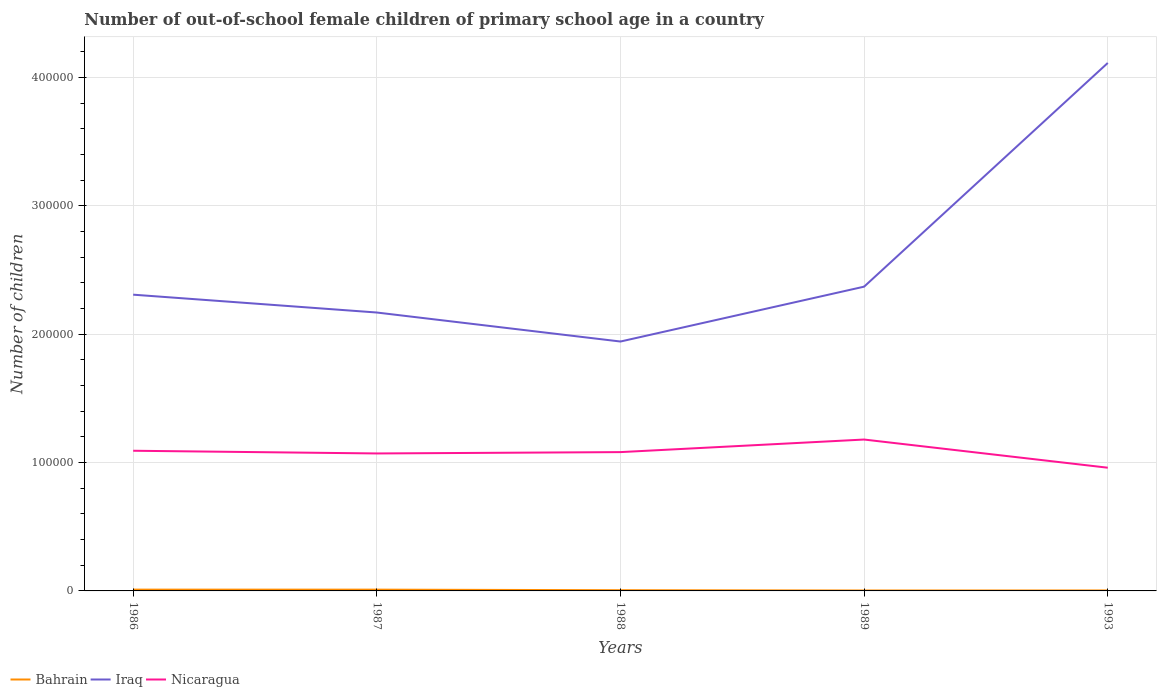How many different coloured lines are there?
Keep it short and to the point. 3. Does the line corresponding to Iraq intersect with the line corresponding to Bahrain?
Your answer should be compact. No. Across all years, what is the maximum number of out-of-school female children in Bahrain?
Offer a very short reply. 341. What is the total number of out-of-school female children in Iraq in the graph?
Give a very brief answer. -2.17e+05. What is the difference between the highest and the second highest number of out-of-school female children in Nicaragua?
Provide a succinct answer. 2.20e+04. What is the difference between the highest and the lowest number of out-of-school female children in Nicaragua?
Offer a very short reply. 3. Is the number of out-of-school female children in Nicaragua strictly greater than the number of out-of-school female children in Iraq over the years?
Ensure brevity in your answer.  Yes. What is the difference between two consecutive major ticks on the Y-axis?
Give a very brief answer. 1.00e+05. Does the graph contain any zero values?
Ensure brevity in your answer.  No. Does the graph contain grids?
Keep it short and to the point. Yes. Where does the legend appear in the graph?
Give a very brief answer. Bottom left. What is the title of the graph?
Your answer should be compact. Number of out-of-school female children of primary school age in a country. Does "Venezuela" appear as one of the legend labels in the graph?
Make the answer very short. No. What is the label or title of the X-axis?
Your answer should be very brief. Years. What is the label or title of the Y-axis?
Make the answer very short. Number of children. What is the Number of children of Bahrain in 1986?
Your answer should be very brief. 1012. What is the Number of children in Iraq in 1986?
Your answer should be very brief. 2.31e+05. What is the Number of children in Nicaragua in 1986?
Offer a terse response. 1.09e+05. What is the Number of children in Bahrain in 1987?
Give a very brief answer. 1002. What is the Number of children in Iraq in 1987?
Give a very brief answer. 2.17e+05. What is the Number of children of Nicaragua in 1987?
Offer a very short reply. 1.07e+05. What is the Number of children in Bahrain in 1988?
Give a very brief answer. 556. What is the Number of children in Iraq in 1988?
Make the answer very short. 1.94e+05. What is the Number of children in Nicaragua in 1988?
Give a very brief answer. 1.08e+05. What is the Number of children of Bahrain in 1989?
Offer a terse response. 341. What is the Number of children in Iraq in 1989?
Provide a short and direct response. 2.37e+05. What is the Number of children of Nicaragua in 1989?
Make the answer very short. 1.18e+05. What is the Number of children of Bahrain in 1993?
Give a very brief answer. 360. What is the Number of children of Iraq in 1993?
Make the answer very short. 4.11e+05. What is the Number of children in Nicaragua in 1993?
Offer a very short reply. 9.60e+04. Across all years, what is the maximum Number of children in Bahrain?
Provide a short and direct response. 1012. Across all years, what is the maximum Number of children in Iraq?
Give a very brief answer. 4.11e+05. Across all years, what is the maximum Number of children of Nicaragua?
Offer a terse response. 1.18e+05. Across all years, what is the minimum Number of children of Bahrain?
Provide a succinct answer. 341. Across all years, what is the minimum Number of children of Iraq?
Your answer should be compact. 1.94e+05. Across all years, what is the minimum Number of children of Nicaragua?
Your answer should be very brief. 9.60e+04. What is the total Number of children in Bahrain in the graph?
Provide a succinct answer. 3271. What is the total Number of children in Iraq in the graph?
Give a very brief answer. 1.29e+06. What is the total Number of children of Nicaragua in the graph?
Provide a succinct answer. 5.39e+05. What is the difference between the Number of children in Iraq in 1986 and that in 1987?
Make the answer very short. 1.39e+04. What is the difference between the Number of children of Nicaragua in 1986 and that in 1987?
Your response must be concise. 2105. What is the difference between the Number of children of Bahrain in 1986 and that in 1988?
Your answer should be compact. 456. What is the difference between the Number of children in Iraq in 1986 and that in 1988?
Offer a terse response. 3.65e+04. What is the difference between the Number of children in Nicaragua in 1986 and that in 1988?
Provide a short and direct response. 1050. What is the difference between the Number of children of Bahrain in 1986 and that in 1989?
Offer a very short reply. 671. What is the difference between the Number of children in Iraq in 1986 and that in 1989?
Ensure brevity in your answer.  -6251. What is the difference between the Number of children in Nicaragua in 1986 and that in 1989?
Give a very brief answer. -8746. What is the difference between the Number of children in Bahrain in 1986 and that in 1993?
Your answer should be very brief. 652. What is the difference between the Number of children of Iraq in 1986 and that in 1993?
Your response must be concise. -1.81e+05. What is the difference between the Number of children in Nicaragua in 1986 and that in 1993?
Keep it short and to the point. 1.32e+04. What is the difference between the Number of children of Bahrain in 1987 and that in 1988?
Offer a very short reply. 446. What is the difference between the Number of children of Iraq in 1987 and that in 1988?
Offer a terse response. 2.26e+04. What is the difference between the Number of children in Nicaragua in 1987 and that in 1988?
Your answer should be very brief. -1055. What is the difference between the Number of children in Bahrain in 1987 and that in 1989?
Keep it short and to the point. 661. What is the difference between the Number of children of Iraq in 1987 and that in 1989?
Provide a succinct answer. -2.02e+04. What is the difference between the Number of children of Nicaragua in 1987 and that in 1989?
Offer a very short reply. -1.09e+04. What is the difference between the Number of children of Bahrain in 1987 and that in 1993?
Your answer should be compact. 642. What is the difference between the Number of children in Iraq in 1987 and that in 1993?
Offer a terse response. -1.94e+05. What is the difference between the Number of children in Nicaragua in 1987 and that in 1993?
Your response must be concise. 1.11e+04. What is the difference between the Number of children of Bahrain in 1988 and that in 1989?
Your response must be concise. 215. What is the difference between the Number of children of Iraq in 1988 and that in 1989?
Your response must be concise. -4.28e+04. What is the difference between the Number of children in Nicaragua in 1988 and that in 1989?
Keep it short and to the point. -9796. What is the difference between the Number of children in Bahrain in 1988 and that in 1993?
Your answer should be compact. 196. What is the difference between the Number of children in Iraq in 1988 and that in 1993?
Make the answer very short. -2.17e+05. What is the difference between the Number of children of Nicaragua in 1988 and that in 1993?
Ensure brevity in your answer.  1.22e+04. What is the difference between the Number of children in Iraq in 1989 and that in 1993?
Ensure brevity in your answer.  -1.74e+05. What is the difference between the Number of children of Nicaragua in 1989 and that in 1993?
Ensure brevity in your answer.  2.20e+04. What is the difference between the Number of children in Bahrain in 1986 and the Number of children in Iraq in 1987?
Give a very brief answer. -2.16e+05. What is the difference between the Number of children of Bahrain in 1986 and the Number of children of Nicaragua in 1987?
Give a very brief answer. -1.06e+05. What is the difference between the Number of children of Iraq in 1986 and the Number of children of Nicaragua in 1987?
Your response must be concise. 1.24e+05. What is the difference between the Number of children of Bahrain in 1986 and the Number of children of Iraq in 1988?
Make the answer very short. -1.93e+05. What is the difference between the Number of children of Bahrain in 1986 and the Number of children of Nicaragua in 1988?
Give a very brief answer. -1.07e+05. What is the difference between the Number of children in Iraq in 1986 and the Number of children in Nicaragua in 1988?
Offer a very short reply. 1.23e+05. What is the difference between the Number of children in Bahrain in 1986 and the Number of children in Iraq in 1989?
Your response must be concise. -2.36e+05. What is the difference between the Number of children of Bahrain in 1986 and the Number of children of Nicaragua in 1989?
Provide a succinct answer. -1.17e+05. What is the difference between the Number of children of Iraq in 1986 and the Number of children of Nicaragua in 1989?
Your response must be concise. 1.13e+05. What is the difference between the Number of children of Bahrain in 1986 and the Number of children of Iraq in 1993?
Your answer should be very brief. -4.10e+05. What is the difference between the Number of children in Bahrain in 1986 and the Number of children in Nicaragua in 1993?
Your response must be concise. -9.50e+04. What is the difference between the Number of children of Iraq in 1986 and the Number of children of Nicaragua in 1993?
Your answer should be compact. 1.35e+05. What is the difference between the Number of children in Bahrain in 1987 and the Number of children in Iraq in 1988?
Offer a terse response. -1.93e+05. What is the difference between the Number of children in Bahrain in 1987 and the Number of children in Nicaragua in 1988?
Your answer should be very brief. -1.07e+05. What is the difference between the Number of children in Iraq in 1987 and the Number of children in Nicaragua in 1988?
Offer a terse response. 1.09e+05. What is the difference between the Number of children of Bahrain in 1987 and the Number of children of Iraq in 1989?
Keep it short and to the point. -2.36e+05. What is the difference between the Number of children in Bahrain in 1987 and the Number of children in Nicaragua in 1989?
Your response must be concise. -1.17e+05. What is the difference between the Number of children in Iraq in 1987 and the Number of children in Nicaragua in 1989?
Provide a succinct answer. 9.90e+04. What is the difference between the Number of children in Bahrain in 1987 and the Number of children in Iraq in 1993?
Give a very brief answer. -4.10e+05. What is the difference between the Number of children in Bahrain in 1987 and the Number of children in Nicaragua in 1993?
Offer a very short reply. -9.50e+04. What is the difference between the Number of children of Iraq in 1987 and the Number of children of Nicaragua in 1993?
Make the answer very short. 1.21e+05. What is the difference between the Number of children in Bahrain in 1988 and the Number of children in Iraq in 1989?
Provide a succinct answer. -2.37e+05. What is the difference between the Number of children in Bahrain in 1988 and the Number of children in Nicaragua in 1989?
Provide a succinct answer. -1.17e+05. What is the difference between the Number of children in Iraq in 1988 and the Number of children in Nicaragua in 1989?
Provide a succinct answer. 7.64e+04. What is the difference between the Number of children in Bahrain in 1988 and the Number of children in Iraq in 1993?
Give a very brief answer. -4.11e+05. What is the difference between the Number of children in Bahrain in 1988 and the Number of children in Nicaragua in 1993?
Offer a terse response. -9.55e+04. What is the difference between the Number of children in Iraq in 1988 and the Number of children in Nicaragua in 1993?
Give a very brief answer. 9.83e+04. What is the difference between the Number of children in Bahrain in 1989 and the Number of children in Iraq in 1993?
Offer a terse response. -4.11e+05. What is the difference between the Number of children of Bahrain in 1989 and the Number of children of Nicaragua in 1993?
Provide a short and direct response. -9.57e+04. What is the difference between the Number of children in Iraq in 1989 and the Number of children in Nicaragua in 1993?
Offer a very short reply. 1.41e+05. What is the average Number of children of Bahrain per year?
Your answer should be compact. 654.2. What is the average Number of children of Iraq per year?
Your answer should be very brief. 2.58e+05. What is the average Number of children of Nicaragua per year?
Make the answer very short. 1.08e+05. In the year 1986, what is the difference between the Number of children in Bahrain and Number of children in Iraq?
Ensure brevity in your answer.  -2.30e+05. In the year 1986, what is the difference between the Number of children in Bahrain and Number of children in Nicaragua?
Provide a succinct answer. -1.08e+05. In the year 1986, what is the difference between the Number of children in Iraq and Number of children in Nicaragua?
Your answer should be very brief. 1.22e+05. In the year 1987, what is the difference between the Number of children in Bahrain and Number of children in Iraq?
Make the answer very short. -2.16e+05. In the year 1987, what is the difference between the Number of children of Bahrain and Number of children of Nicaragua?
Your response must be concise. -1.06e+05. In the year 1987, what is the difference between the Number of children in Iraq and Number of children in Nicaragua?
Your answer should be very brief. 1.10e+05. In the year 1988, what is the difference between the Number of children of Bahrain and Number of children of Iraq?
Your response must be concise. -1.94e+05. In the year 1988, what is the difference between the Number of children of Bahrain and Number of children of Nicaragua?
Ensure brevity in your answer.  -1.08e+05. In the year 1988, what is the difference between the Number of children in Iraq and Number of children in Nicaragua?
Your answer should be very brief. 8.62e+04. In the year 1989, what is the difference between the Number of children in Bahrain and Number of children in Iraq?
Your answer should be compact. -2.37e+05. In the year 1989, what is the difference between the Number of children of Bahrain and Number of children of Nicaragua?
Your response must be concise. -1.18e+05. In the year 1989, what is the difference between the Number of children in Iraq and Number of children in Nicaragua?
Ensure brevity in your answer.  1.19e+05. In the year 1993, what is the difference between the Number of children in Bahrain and Number of children in Iraq?
Your answer should be very brief. -4.11e+05. In the year 1993, what is the difference between the Number of children of Bahrain and Number of children of Nicaragua?
Give a very brief answer. -9.57e+04. In the year 1993, what is the difference between the Number of children in Iraq and Number of children in Nicaragua?
Your response must be concise. 3.15e+05. What is the ratio of the Number of children in Iraq in 1986 to that in 1987?
Provide a short and direct response. 1.06. What is the ratio of the Number of children of Nicaragua in 1986 to that in 1987?
Keep it short and to the point. 1.02. What is the ratio of the Number of children in Bahrain in 1986 to that in 1988?
Offer a very short reply. 1.82. What is the ratio of the Number of children in Iraq in 1986 to that in 1988?
Ensure brevity in your answer.  1.19. What is the ratio of the Number of children of Nicaragua in 1986 to that in 1988?
Your answer should be compact. 1.01. What is the ratio of the Number of children in Bahrain in 1986 to that in 1989?
Offer a very short reply. 2.97. What is the ratio of the Number of children of Iraq in 1986 to that in 1989?
Offer a very short reply. 0.97. What is the ratio of the Number of children of Nicaragua in 1986 to that in 1989?
Your answer should be compact. 0.93. What is the ratio of the Number of children of Bahrain in 1986 to that in 1993?
Your response must be concise. 2.81. What is the ratio of the Number of children of Iraq in 1986 to that in 1993?
Offer a terse response. 0.56. What is the ratio of the Number of children in Nicaragua in 1986 to that in 1993?
Provide a succinct answer. 1.14. What is the ratio of the Number of children of Bahrain in 1987 to that in 1988?
Ensure brevity in your answer.  1.8. What is the ratio of the Number of children of Iraq in 1987 to that in 1988?
Give a very brief answer. 1.12. What is the ratio of the Number of children of Nicaragua in 1987 to that in 1988?
Offer a terse response. 0.99. What is the ratio of the Number of children in Bahrain in 1987 to that in 1989?
Your response must be concise. 2.94. What is the ratio of the Number of children in Iraq in 1987 to that in 1989?
Your response must be concise. 0.92. What is the ratio of the Number of children in Nicaragua in 1987 to that in 1989?
Your answer should be very brief. 0.91. What is the ratio of the Number of children in Bahrain in 1987 to that in 1993?
Make the answer very short. 2.78. What is the ratio of the Number of children of Iraq in 1987 to that in 1993?
Ensure brevity in your answer.  0.53. What is the ratio of the Number of children of Nicaragua in 1987 to that in 1993?
Your response must be concise. 1.12. What is the ratio of the Number of children in Bahrain in 1988 to that in 1989?
Your answer should be compact. 1.63. What is the ratio of the Number of children in Iraq in 1988 to that in 1989?
Your response must be concise. 0.82. What is the ratio of the Number of children in Nicaragua in 1988 to that in 1989?
Ensure brevity in your answer.  0.92. What is the ratio of the Number of children in Bahrain in 1988 to that in 1993?
Provide a succinct answer. 1.54. What is the ratio of the Number of children in Iraq in 1988 to that in 1993?
Make the answer very short. 0.47. What is the ratio of the Number of children of Nicaragua in 1988 to that in 1993?
Your response must be concise. 1.13. What is the ratio of the Number of children of Bahrain in 1989 to that in 1993?
Your response must be concise. 0.95. What is the ratio of the Number of children of Iraq in 1989 to that in 1993?
Keep it short and to the point. 0.58. What is the ratio of the Number of children of Nicaragua in 1989 to that in 1993?
Offer a very short reply. 1.23. What is the difference between the highest and the second highest Number of children in Bahrain?
Keep it short and to the point. 10. What is the difference between the highest and the second highest Number of children in Iraq?
Keep it short and to the point. 1.74e+05. What is the difference between the highest and the second highest Number of children in Nicaragua?
Keep it short and to the point. 8746. What is the difference between the highest and the lowest Number of children in Bahrain?
Your answer should be very brief. 671. What is the difference between the highest and the lowest Number of children in Iraq?
Make the answer very short. 2.17e+05. What is the difference between the highest and the lowest Number of children of Nicaragua?
Keep it short and to the point. 2.20e+04. 